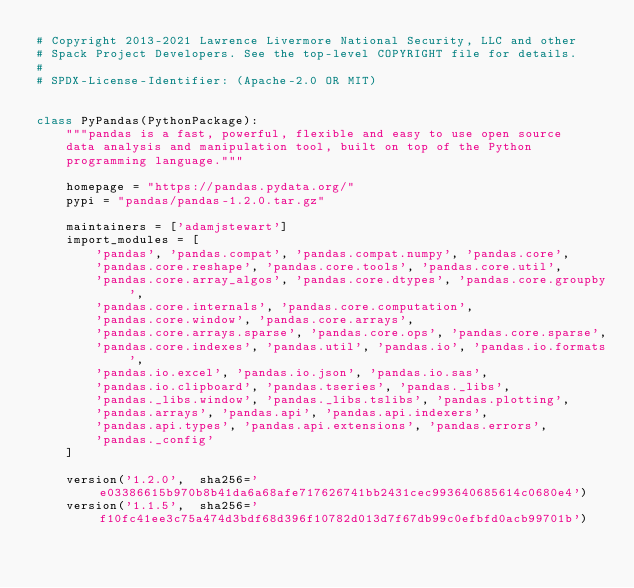Convert code to text. <code><loc_0><loc_0><loc_500><loc_500><_Python_># Copyright 2013-2021 Lawrence Livermore National Security, LLC and other
# Spack Project Developers. See the top-level COPYRIGHT file for details.
#
# SPDX-License-Identifier: (Apache-2.0 OR MIT)


class PyPandas(PythonPackage):
    """pandas is a fast, powerful, flexible and easy to use open source
    data analysis and manipulation tool, built on top of the Python
    programming language."""

    homepage = "https://pandas.pydata.org/"
    pypi = "pandas/pandas-1.2.0.tar.gz"

    maintainers = ['adamjstewart']
    import_modules = [
        'pandas', 'pandas.compat', 'pandas.compat.numpy', 'pandas.core',
        'pandas.core.reshape', 'pandas.core.tools', 'pandas.core.util',
        'pandas.core.array_algos', 'pandas.core.dtypes', 'pandas.core.groupby',
        'pandas.core.internals', 'pandas.core.computation',
        'pandas.core.window', 'pandas.core.arrays',
        'pandas.core.arrays.sparse', 'pandas.core.ops', 'pandas.core.sparse',
        'pandas.core.indexes', 'pandas.util', 'pandas.io', 'pandas.io.formats',
        'pandas.io.excel', 'pandas.io.json', 'pandas.io.sas',
        'pandas.io.clipboard', 'pandas.tseries', 'pandas._libs',
        'pandas._libs.window', 'pandas._libs.tslibs', 'pandas.plotting',
        'pandas.arrays', 'pandas.api', 'pandas.api.indexers',
        'pandas.api.types', 'pandas.api.extensions', 'pandas.errors',
        'pandas._config'
    ]

    version('1.2.0',  sha256='e03386615b970b8b41da6a68afe717626741bb2431cec993640685614c0680e4')
    version('1.1.5',  sha256='f10fc41ee3c75a474d3bdf68d396f10782d013d7f67db99c0efbfd0acb99701b')</code> 